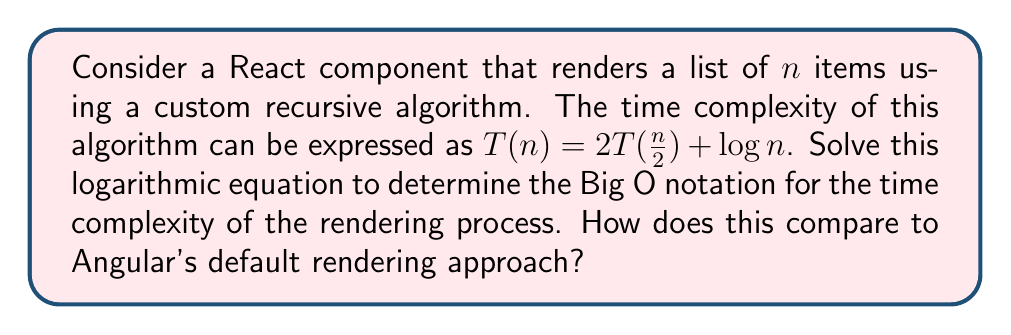Teach me how to tackle this problem. To solve this problem, we'll use the Master Theorem for divide-and-conquer recurrences. The general form is:

$T(n) = aT(\frac{n}{b}) + f(n)$

In our case:
$a = 2$ (number of subproblems)
$b = 2$ (factor by which the problem size is reduced)
$f(n) = \log n$

Let's follow these steps:

1) First, we need to compare $n^{\log_b a}$ with $f(n)$:
   $n^{\log_b a} = n^{\log_2 2} = n^1 = n$

2) We compare $n$ with $\log n$:
   $n$ grows faster than $\log n$

3) This puts us in case 1 of the Master Theorem:
   If $f(n) = O(n^{\log_b a - \epsilon})$ for some $\epsilon > 0$,
   then $T(n) = \Theta(n^{\log_b a})$

4) We can verify that $\log n = O(n^{1-\epsilon})$ for any $\epsilon$ between 0 and 1.

5) Therefore, $T(n) = \Theta(n^{\log_2 2}) = \Theta(n)$

This means the time complexity of the React rendering algorithm is linear, or $O(n)$.

Comparing to Angular:
Angular uses a change detection mechanism that, in the default configuration, has a time complexity of $O(n)$ for $n$ bindings. However, Angular's approach is generally considered less optimized for large applications compared to React's virtual DOM and reconciliation process, which can often result in fewer actual DOM manipulations.
Answer: $O(n)$ 